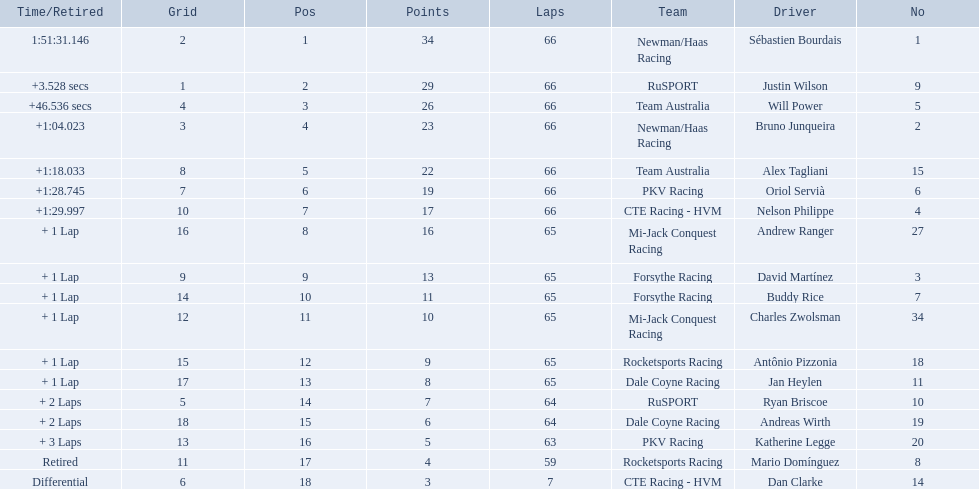What are the names of the drivers who were in position 14 through position 18? Ryan Briscoe, Andreas Wirth, Katherine Legge, Mario Domínguez, Dan Clarke. Of these , which ones didn't finish due to retired or differential? Mario Domínguez, Dan Clarke. Which one of the previous drivers retired? Mario Domínguez. Which of the drivers in question 2 had a differential? Dan Clarke. Would you be able to parse every entry in this table? {'header': ['Time/Retired', 'Grid', 'Pos', 'Points', 'Laps', 'Team', 'Driver', 'No'], 'rows': [['1:51:31.146', '2', '1', '34', '66', 'Newman/Haas Racing', 'Sébastien Bourdais', '1'], ['+3.528 secs', '1', '2', '29', '66', 'RuSPORT', 'Justin Wilson', '9'], ['+46.536 secs', '4', '3', '26', '66', 'Team Australia', 'Will Power', '5'], ['+1:04.023', '3', '4', '23', '66', 'Newman/Haas Racing', 'Bruno Junqueira', '2'], ['+1:18.033', '8', '5', '22', '66', 'Team Australia', 'Alex Tagliani', '15'], ['+1:28.745', '7', '6', '19', '66', 'PKV Racing', 'Oriol Servià', '6'], ['+1:29.997', '10', '7', '17', '66', 'CTE Racing - HVM', 'Nelson Philippe', '4'], ['+ 1 Lap', '16', '8', '16', '65', 'Mi-Jack Conquest Racing', 'Andrew Ranger', '27'], ['+ 1 Lap', '9', '9', '13', '65', 'Forsythe Racing', 'David Martínez', '3'], ['+ 1 Lap', '14', '10', '11', '65', 'Forsythe Racing', 'Buddy Rice', '7'], ['+ 1 Lap', '12', '11', '10', '65', 'Mi-Jack Conquest Racing', 'Charles Zwolsman', '34'], ['+ 1 Lap', '15', '12', '9', '65', 'Rocketsports Racing', 'Antônio Pizzonia', '18'], ['+ 1 Lap', '17', '13', '8', '65', 'Dale Coyne Racing', 'Jan Heylen', '11'], ['+ 2 Laps', '5', '14', '7', '64', 'RuSPORT', 'Ryan Briscoe', '10'], ['+ 2 Laps', '18', '15', '6', '64', 'Dale Coyne Racing', 'Andreas Wirth', '19'], ['+ 3 Laps', '13', '16', '5', '63', 'PKV Racing', 'Katherine Legge', '20'], ['Retired', '11', '17', '4', '59', 'Rocketsports Racing', 'Mario Domínguez', '8'], ['Differential', '6', '18', '3', '7', 'CTE Racing - HVM', 'Dan Clarke', '14']]} 